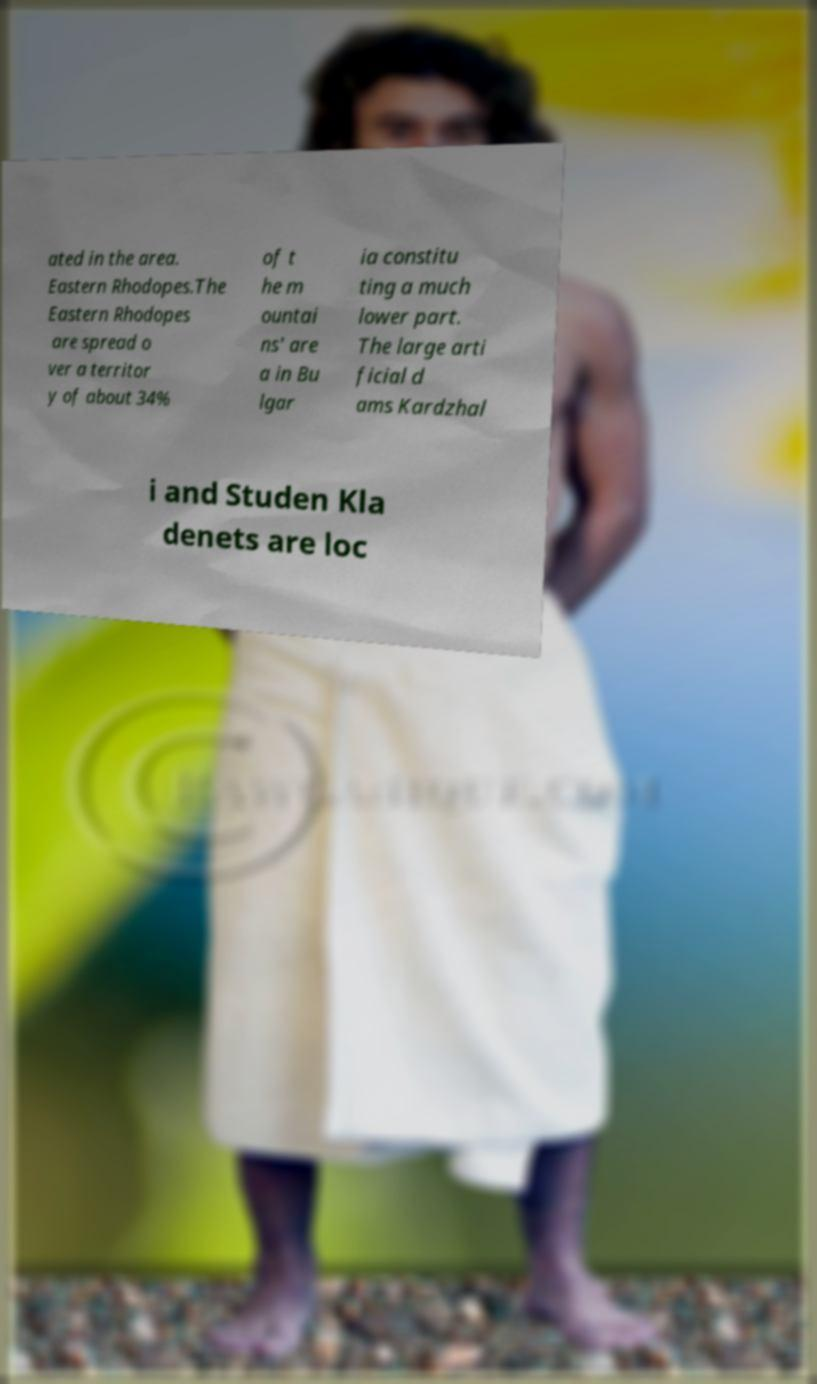Could you extract and type out the text from this image? ated in the area. Eastern Rhodopes.The Eastern Rhodopes are spread o ver a territor y of about 34% of t he m ountai ns' are a in Bu lgar ia constitu ting a much lower part. The large arti ficial d ams Kardzhal i and Studen Kla denets are loc 